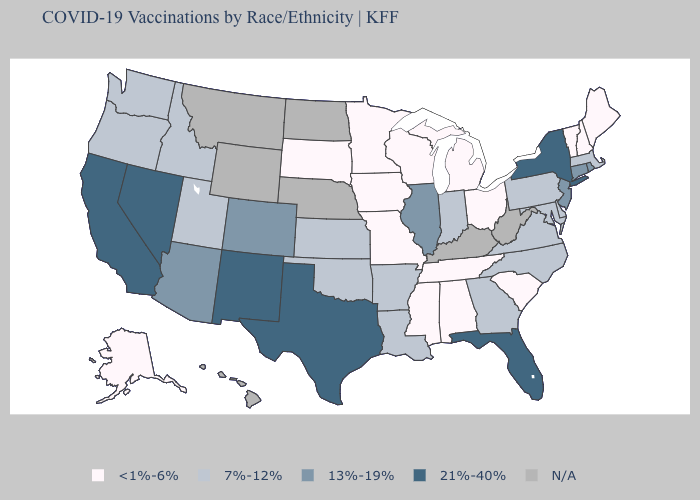What is the value of Alabama?
Short answer required. <1%-6%. What is the value of Tennessee?
Keep it brief. <1%-6%. Which states have the lowest value in the USA?
Keep it brief. Alabama, Alaska, Iowa, Maine, Michigan, Minnesota, Mississippi, Missouri, New Hampshire, Ohio, South Carolina, South Dakota, Tennessee, Vermont, Wisconsin. Which states hav the highest value in the MidWest?
Answer briefly. Illinois. Which states have the lowest value in the USA?
Concise answer only. Alabama, Alaska, Iowa, Maine, Michigan, Minnesota, Mississippi, Missouri, New Hampshire, Ohio, South Carolina, South Dakota, Tennessee, Vermont, Wisconsin. What is the highest value in the USA?
Answer briefly. 21%-40%. What is the highest value in states that border Kentucky?
Be succinct. 13%-19%. Among the states that border Ohio , which have the highest value?
Be succinct. Indiana, Pennsylvania. Among the states that border Louisiana , which have the highest value?
Answer briefly. Texas. Does Georgia have the highest value in the South?
Concise answer only. No. Name the states that have a value in the range N/A?
Keep it brief. Hawaii, Kentucky, Montana, Nebraska, North Dakota, West Virginia, Wyoming. How many symbols are there in the legend?
Keep it brief. 5. Name the states that have a value in the range 13%-19%?
Answer briefly. Arizona, Colorado, Connecticut, Illinois, New Jersey, Rhode Island. 